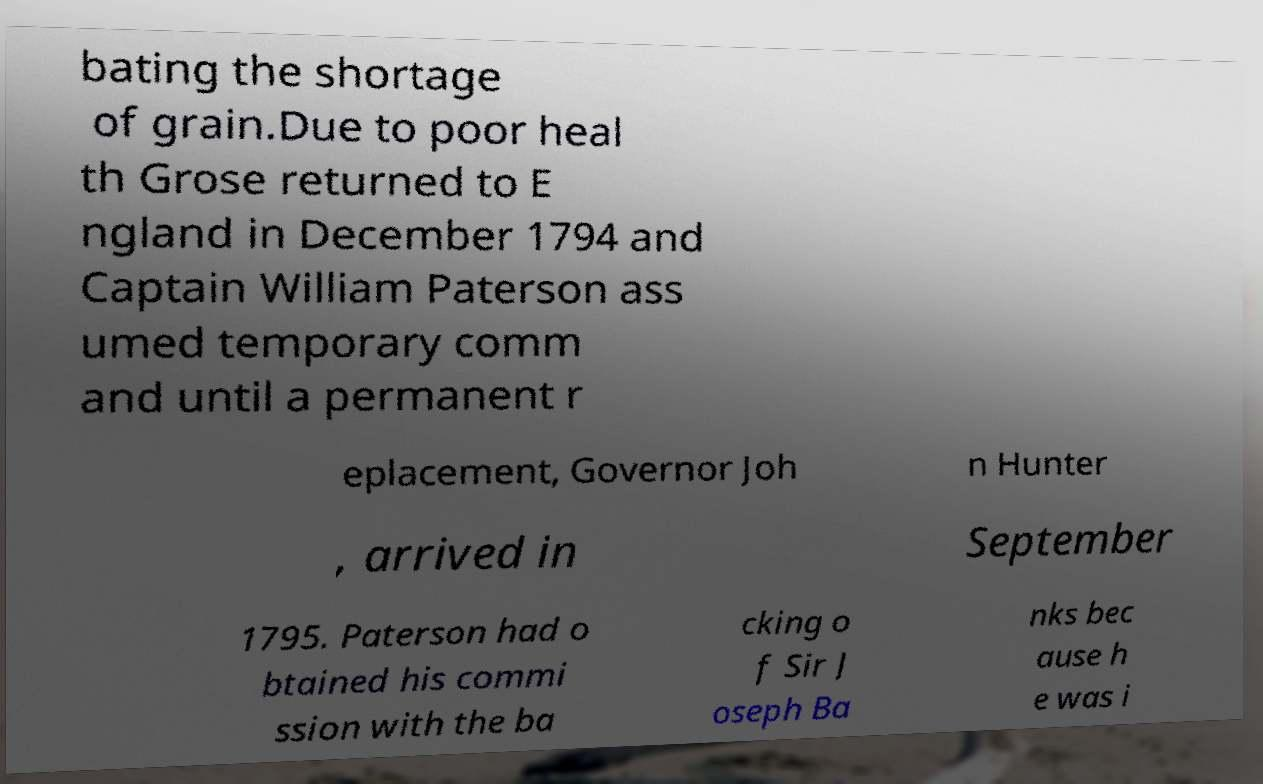Could you assist in decoding the text presented in this image and type it out clearly? bating the shortage of grain.Due to poor heal th Grose returned to E ngland in December 1794 and Captain William Paterson ass umed temporary comm and until a permanent r eplacement, Governor Joh n Hunter , arrived in September 1795. Paterson had o btained his commi ssion with the ba cking o f Sir J oseph Ba nks bec ause h e was i 